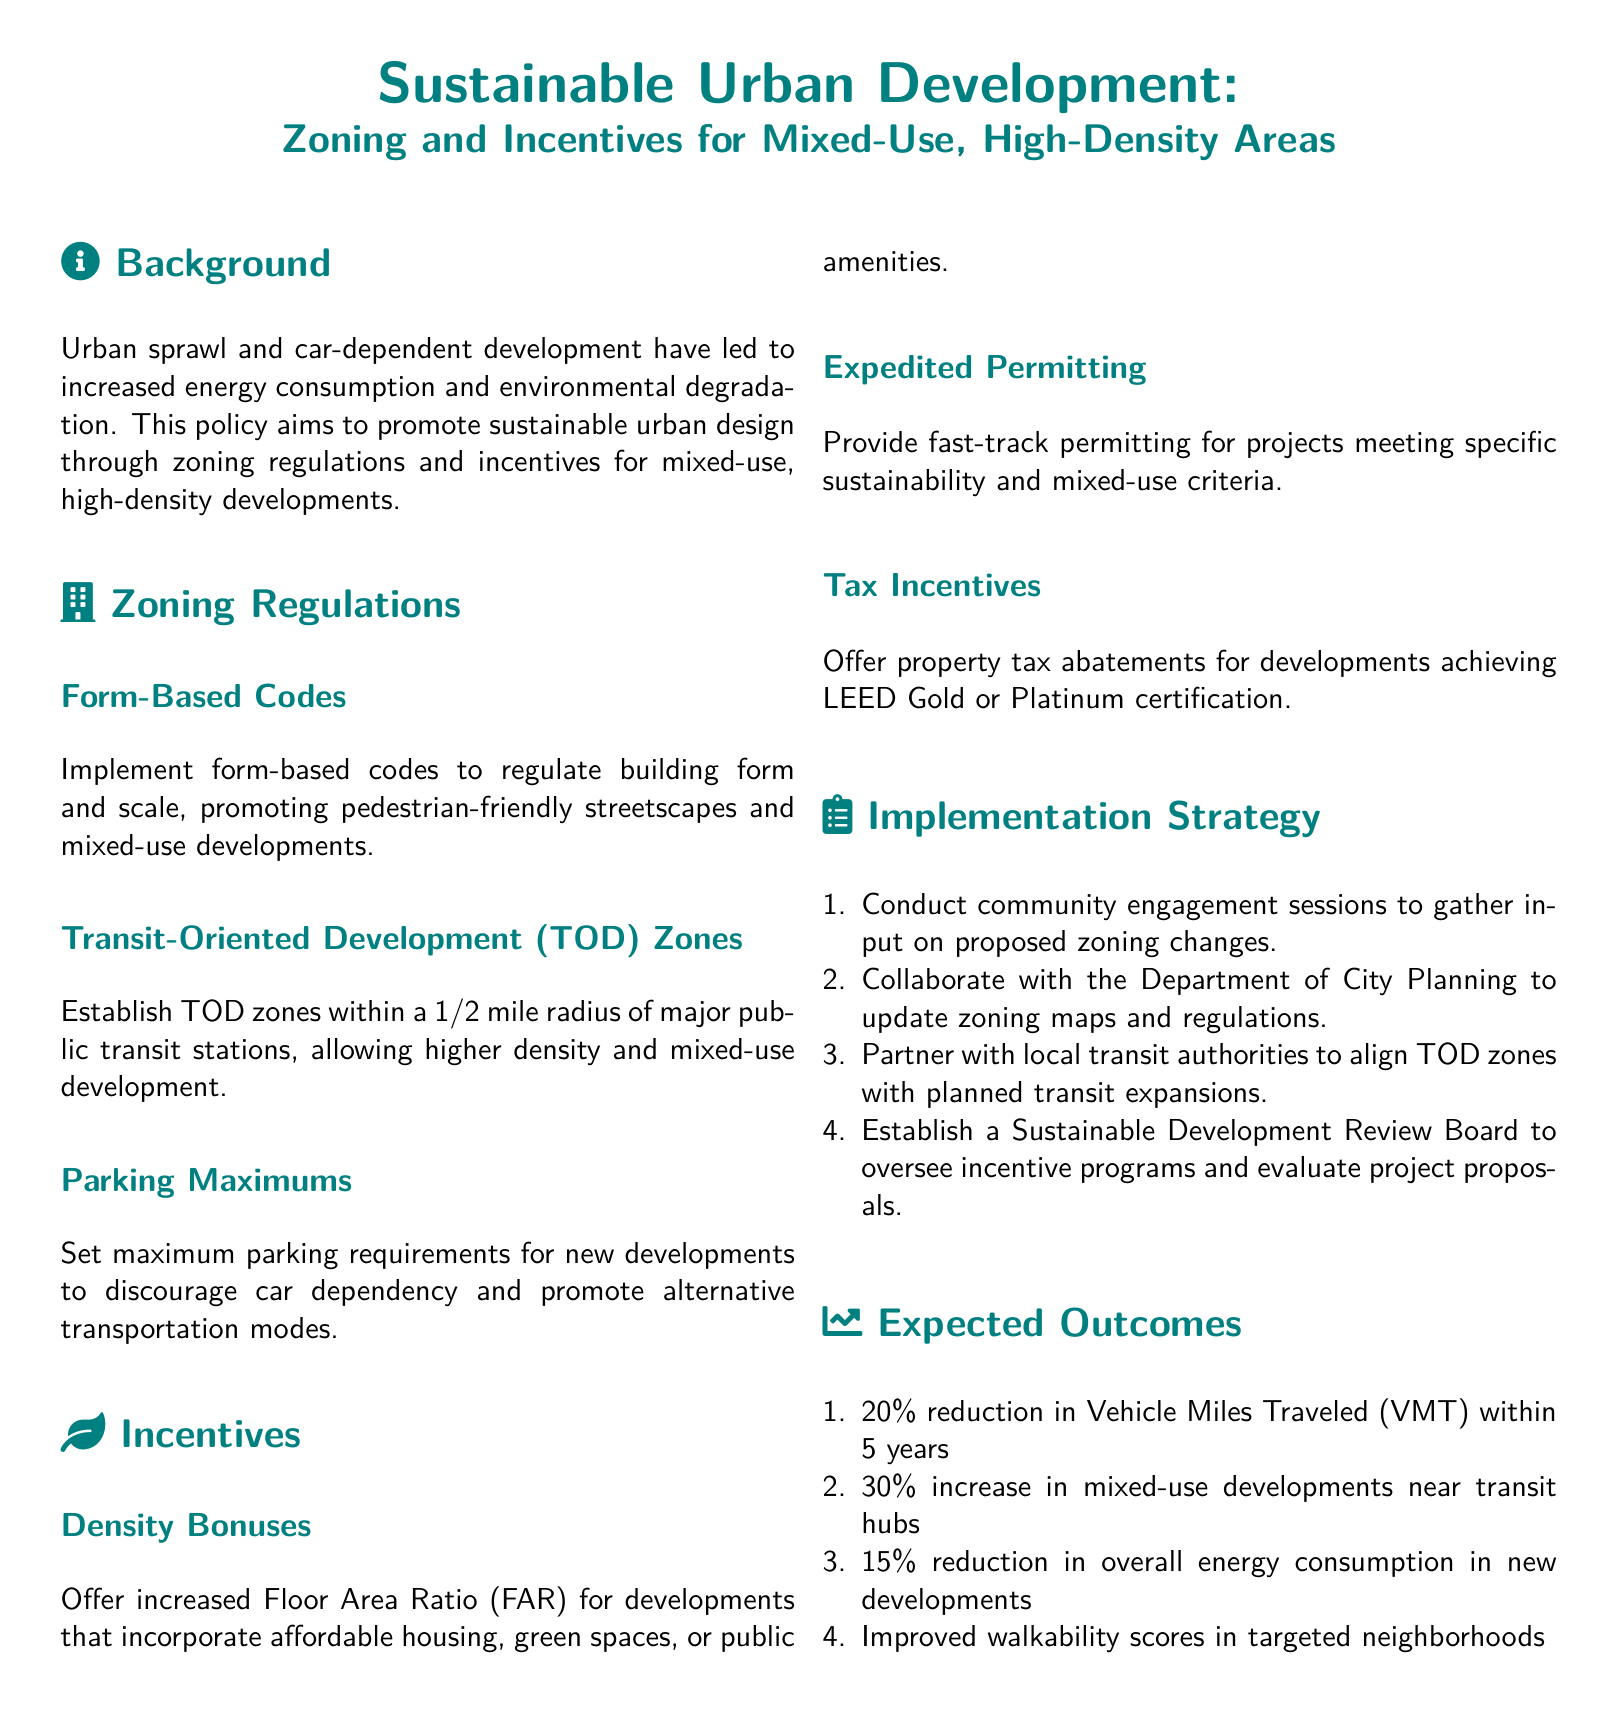What is the main goal of the policy? The policy aims to promote sustainable urban design through zoning regulations and incentives.
Answer: Sustainable urban design What is the radius for Transit-Oriented Development zones? The document specifies establishing TOD zones within a 1/2 mile radius of major public transit stations.
Answer: 1/2 mile What type of incentives are offered for developments achieving LEED certification? The policy offers property tax abatements for developments achieving LEED Gold or Platinum certification.
Answer: Property tax abatements What is the expected reduction in Vehicle Miles Traveled (VMT) within 5 years? The document states an expected 20% reduction in Vehicle Miles Traveled (VMT) within 5 years.
Answer: 20% What is one of the strategies for implementation? One of the strategies is to conduct community engagement sessions to gather input on proposed zoning changes.
Answer: Conduct community engagement sessions How many percent increase in mixed-use developments near transit hubs is expected? The document outlines an expected 30% increase in mixed-use developments near transit hubs.
Answer: 30% What are the maximum parking requirements intended to discourage? The maximum parking requirements are intended to discourage car dependency.
Answer: Car dependency What organization is to be partnered with for aligning TOD zones? The document mentions partnering with local transit authorities for aligning TOD zones.
Answer: Local transit authorities 